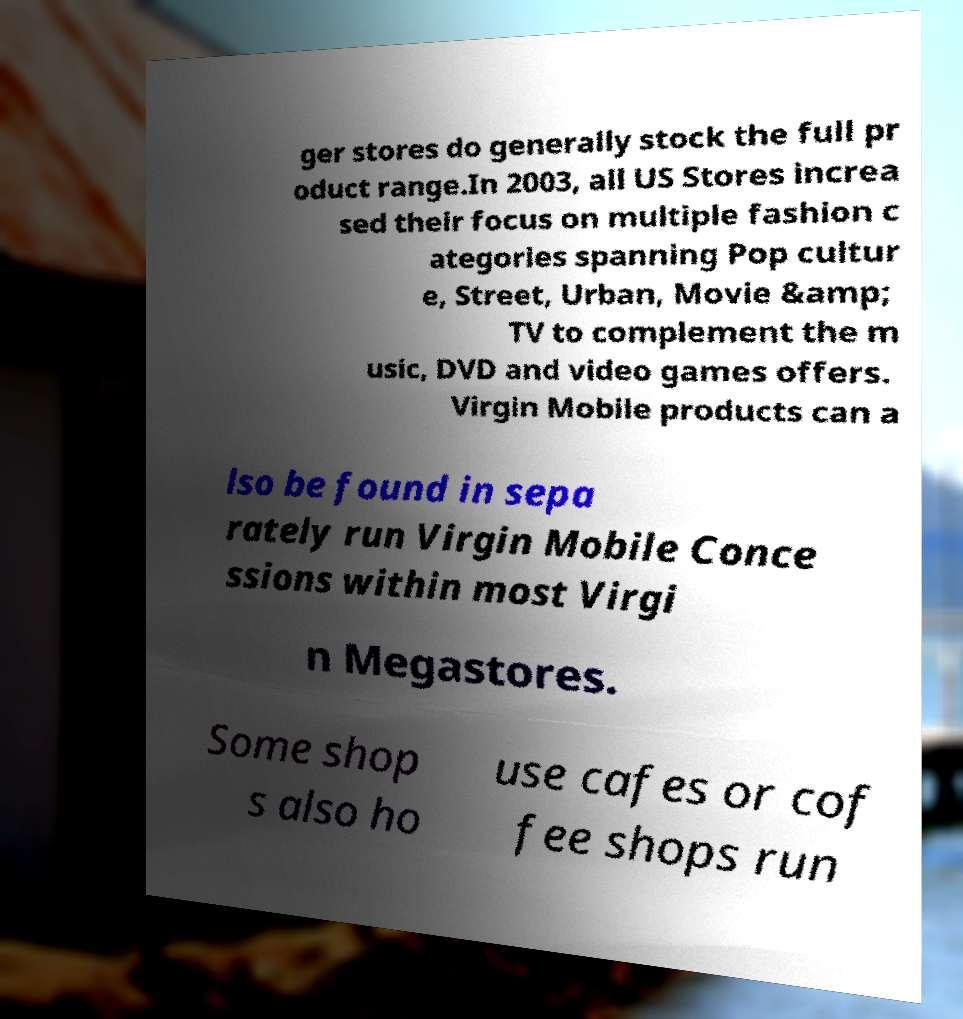Can you accurately transcribe the text from the provided image for me? ger stores do generally stock the full pr oduct range.In 2003, all US Stores increa sed their focus on multiple fashion c ategories spanning Pop cultur e, Street, Urban, Movie &amp; TV to complement the m usic, DVD and video games offers. Virgin Mobile products can a lso be found in sepa rately run Virgin Mobile Conce ssions within most Virgi n Megastores. Some shop s also ho use cafes or cof fee shops run 